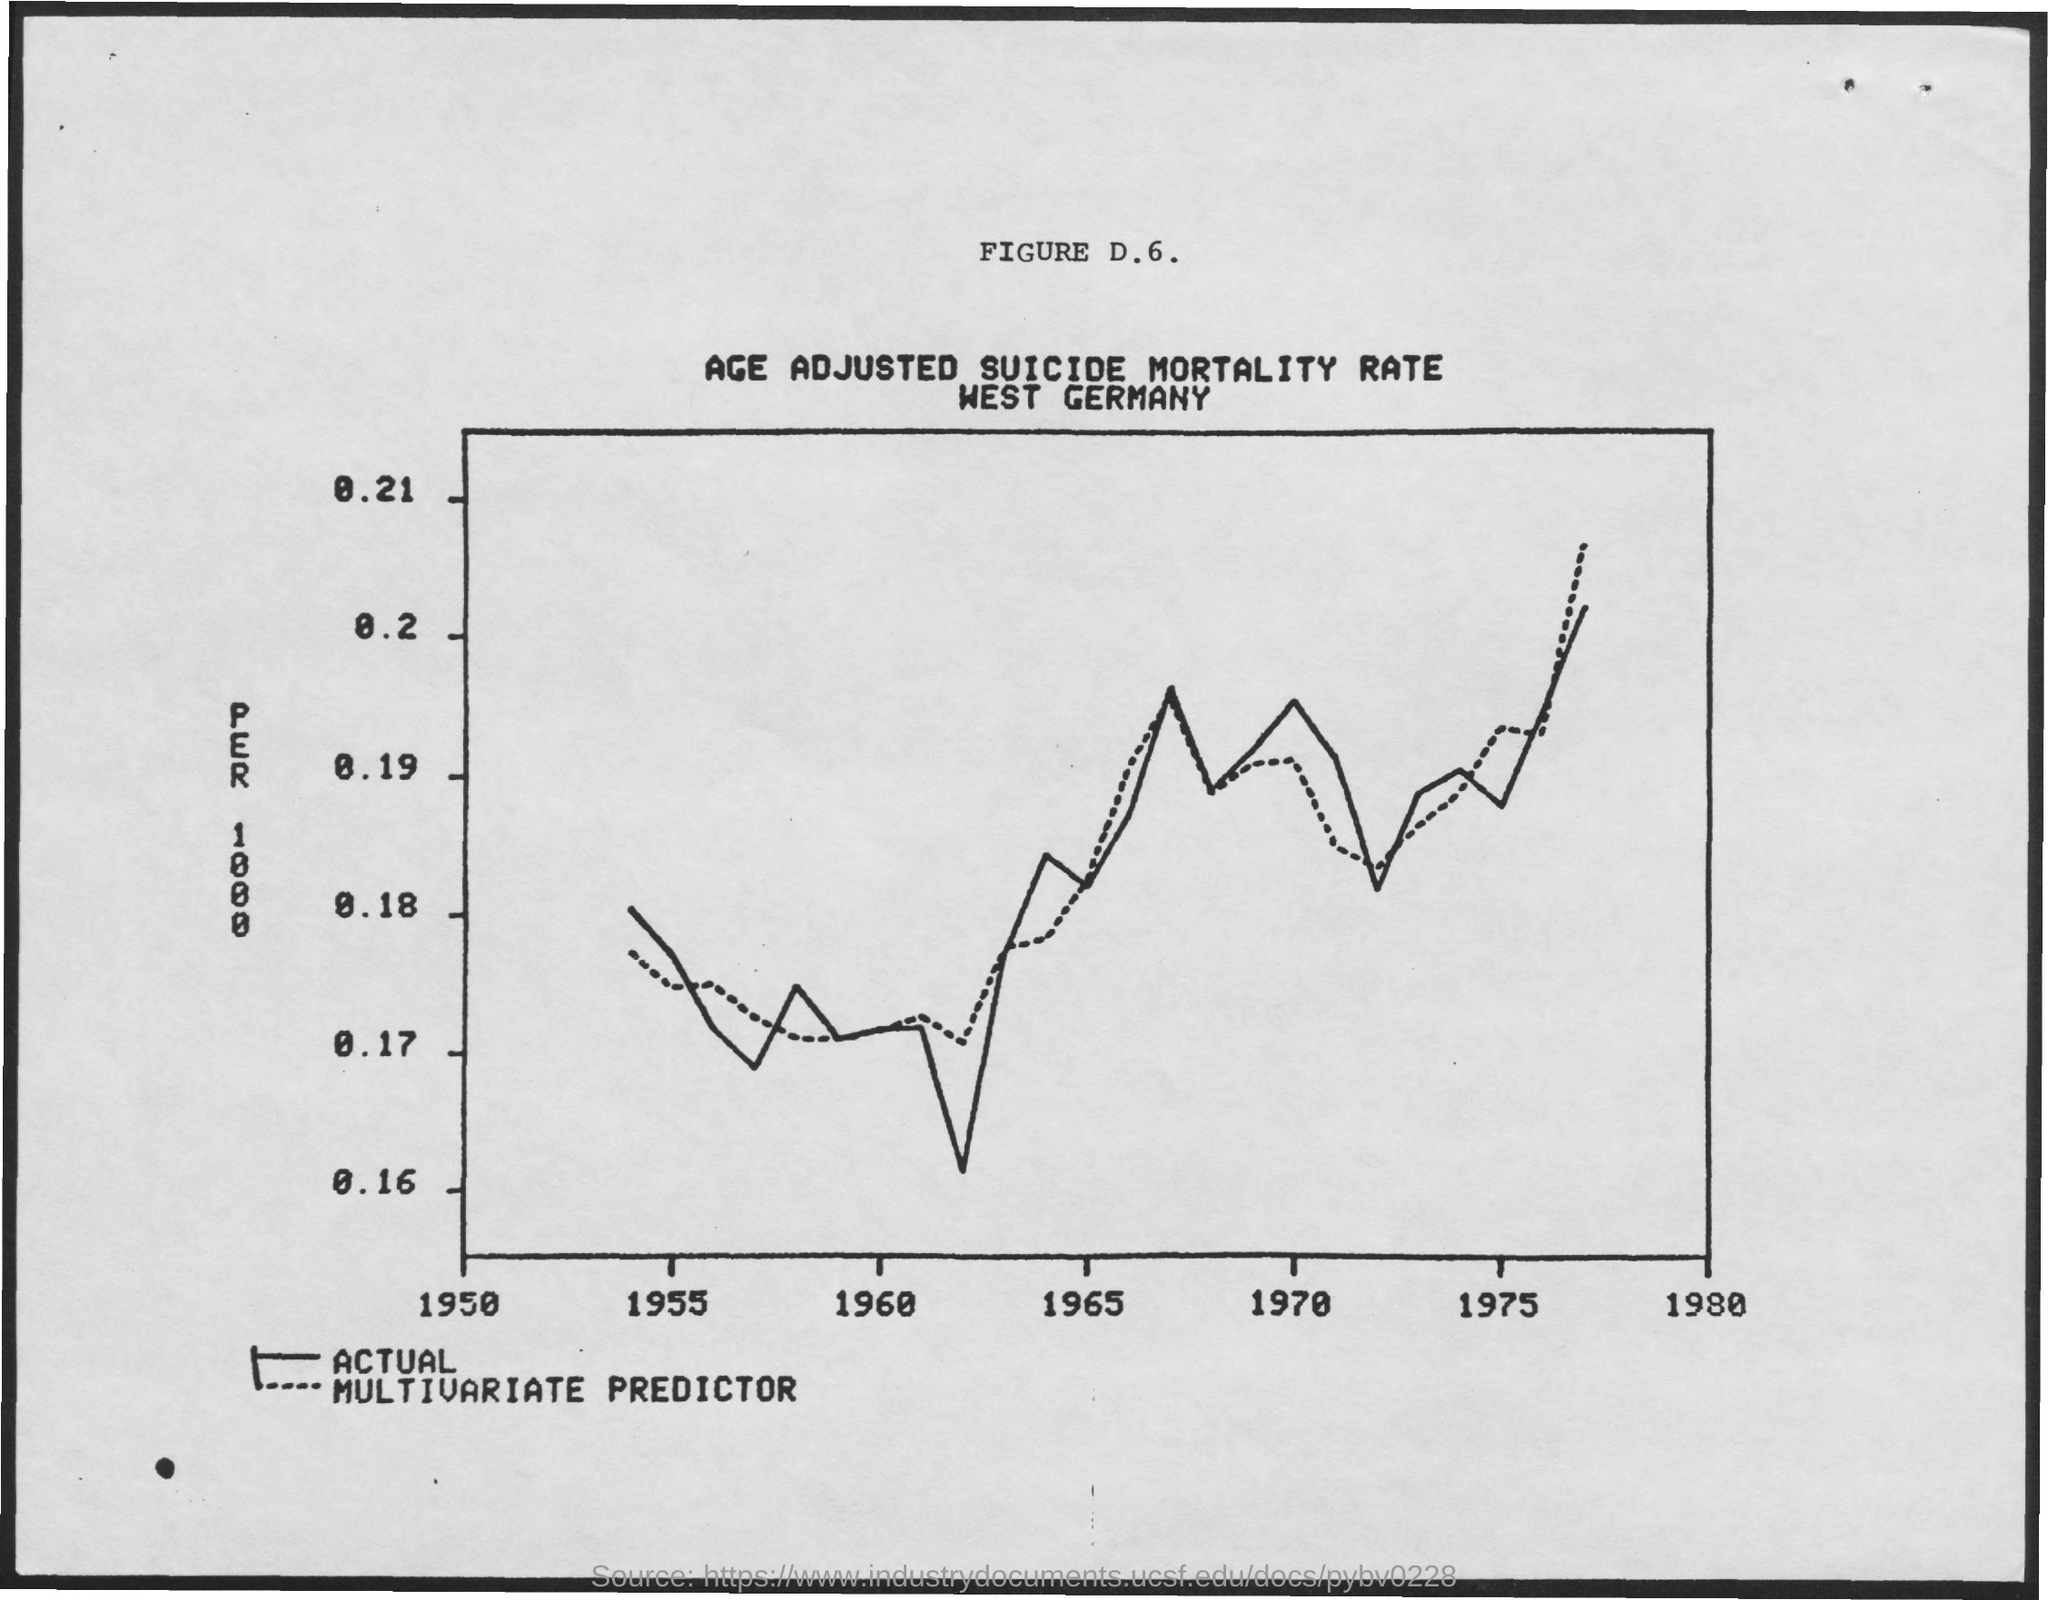What is the name of the country mentioned in the document?
Make the answer very short. West Germany. 